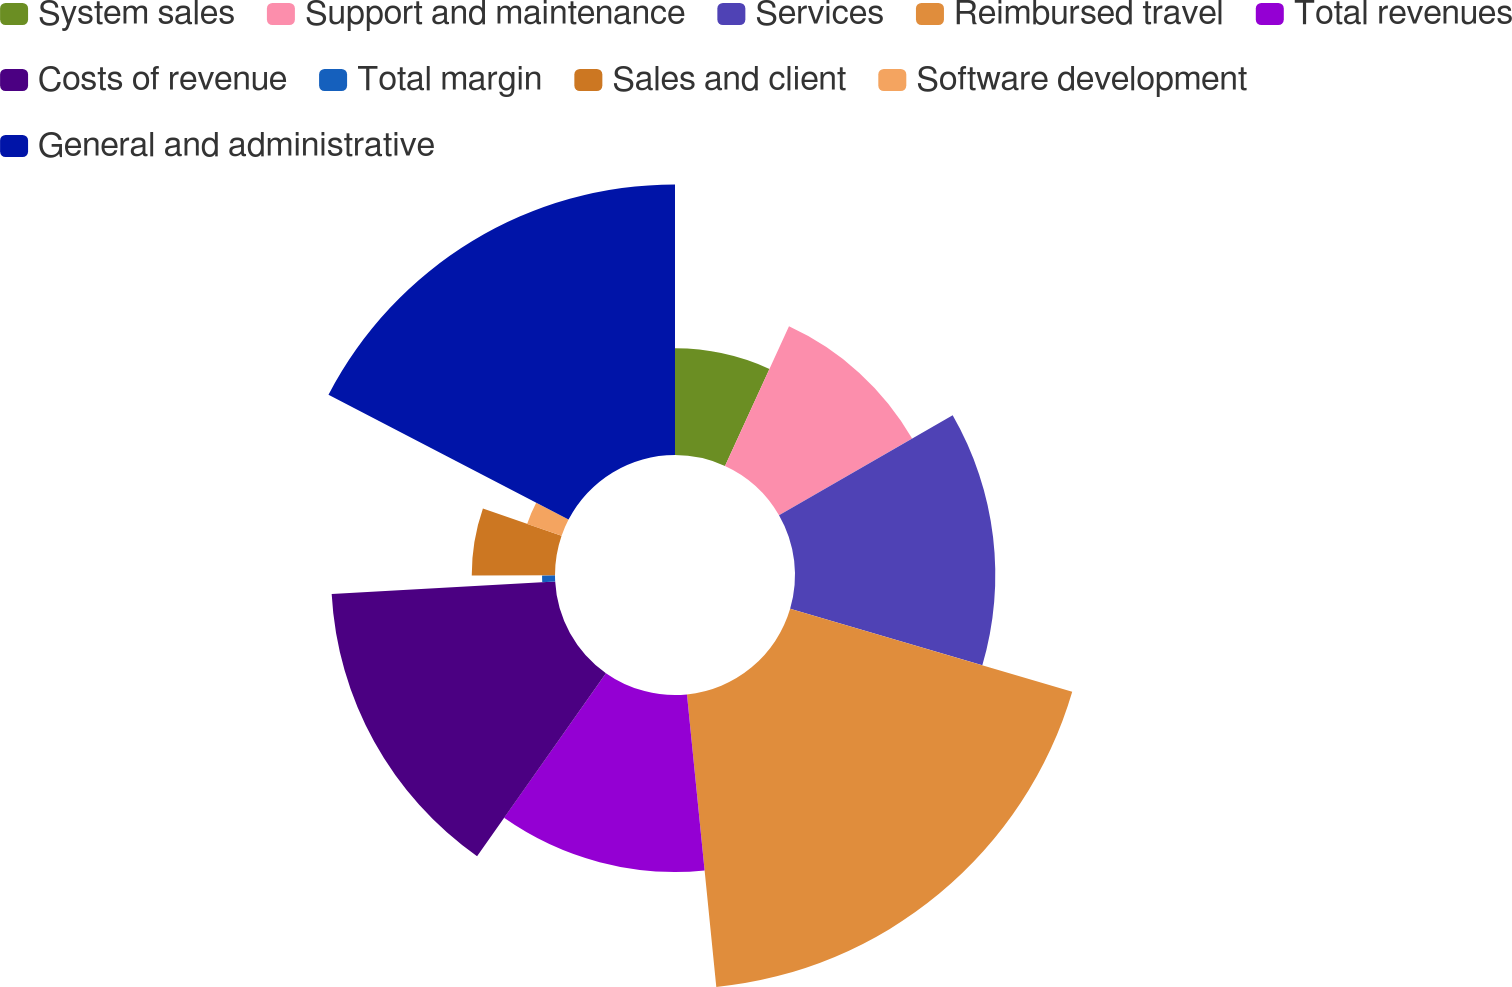Convert chart. <chart><loc_0><loc_0><loc_500><loc_500><pie_chart><fcel>System sales<fcel>Support and maintenance<fcel>Services<fcel>Reimbursed travel<fcel>Total revenues<fcel>Costs of revenue<fcel>Total margin<fcel>Sales and client<fcel>Software development<fcel>General and administrative<nl><fcel>6.84%<fcel>9.85%<fcel>12.85%<fcel>18.86%<fcel>11.35%<fcel>14.36%<fcel>0.83%<fcel>5.34%<fcel>2.34%<fcel>17.36%<nl></chart> 